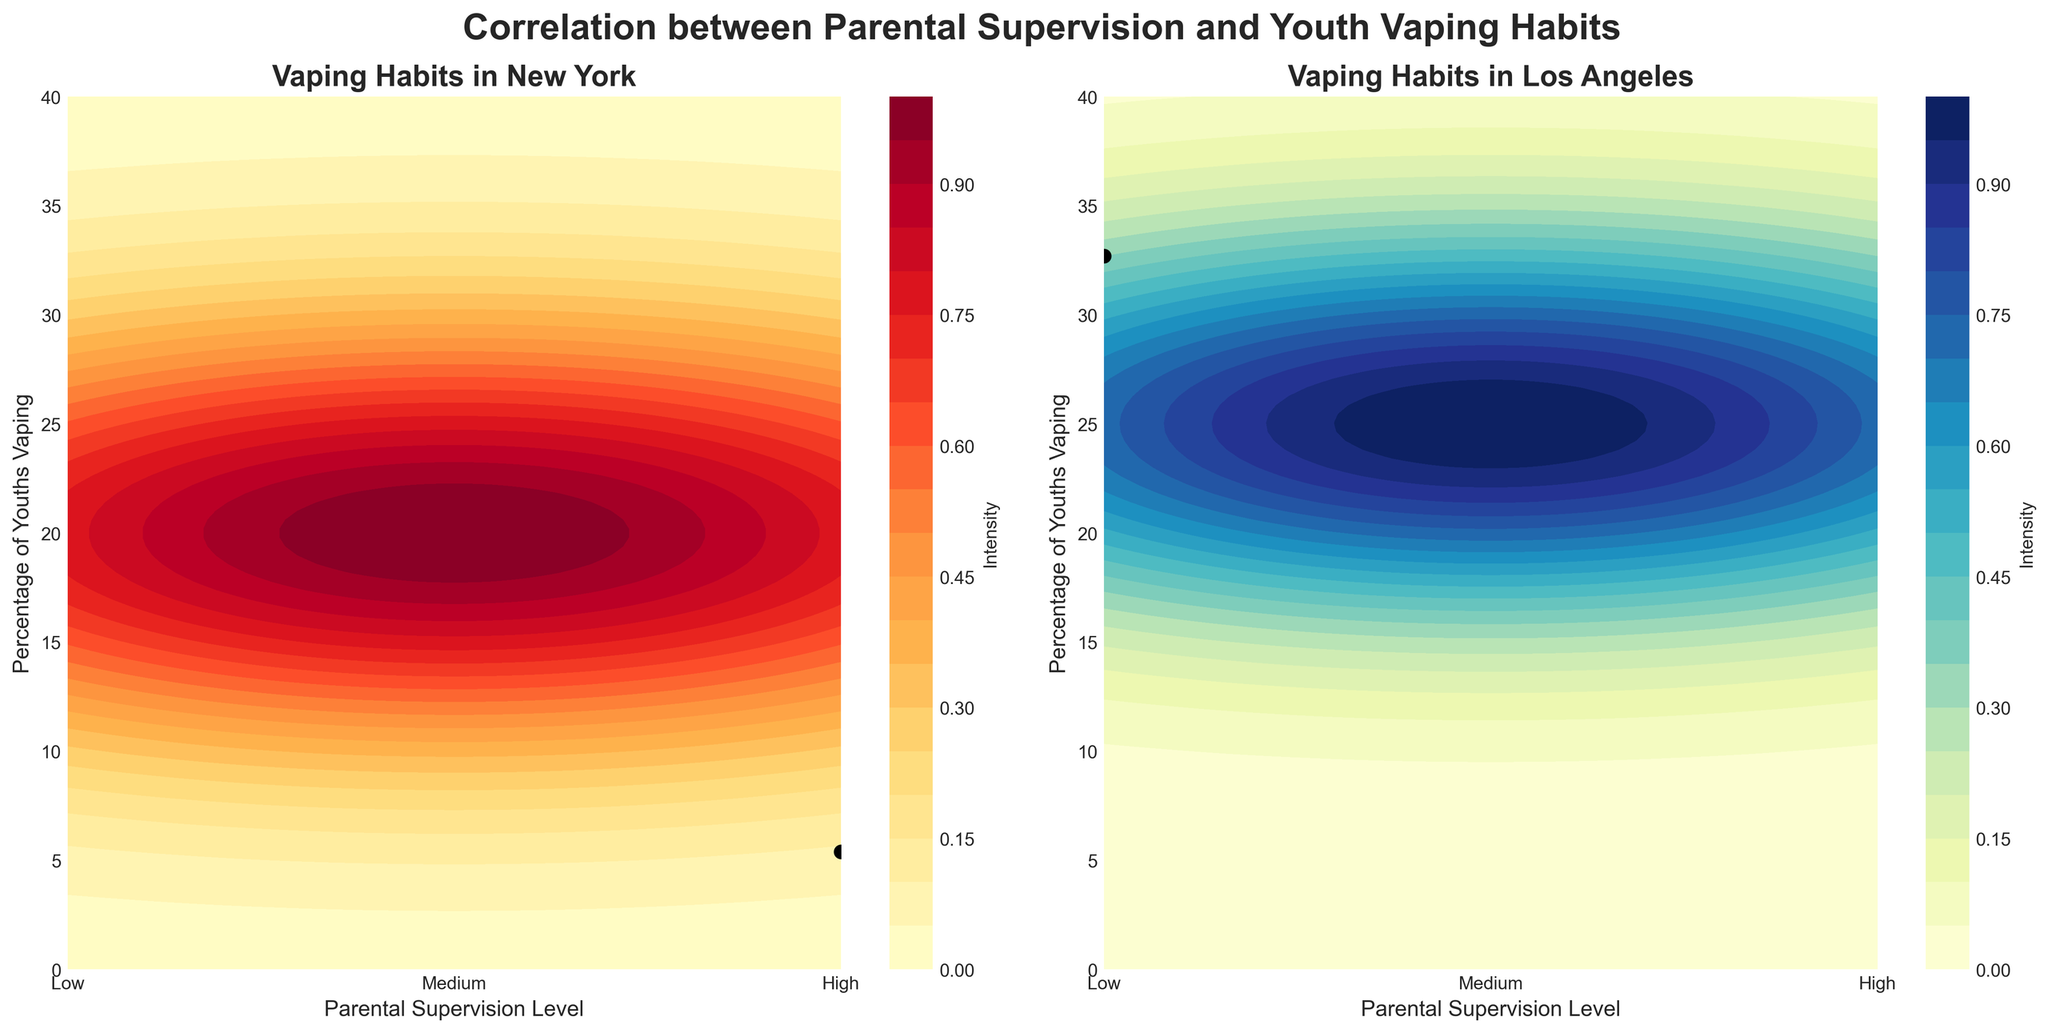What is the title of the first subplot on the left? The first subplot on the left has a title at the top, which can be read directly from the figure.
Answer: Vaping Habits in New York What does the color intensity represent in both subplots? Each subplot has a color bar that indicates what the colors stand for. The intensity is labeled as 'Intensity' in the color bar.
Answer: Intensity What does the y-axis represent in both subplots? The label on the y-axis of both subplots indicates what the y-axis represents.
Answer: Percentage of Youths Vaping Which city has the higher percentage of youths vaping with medium parental supervision? By locating the medium parental supervision marker (5 on the x-axis) and noting the corresponding points for both subplots, we can compare the y-values.
Answer: Los Angeles What is the correlation between parental supervision and youth vaping habits in New York? The contour lines and placement of data points suggest that as the parental supervision level increases, the percentage of youths vaping decreases.
Answer: Negative correlation How many data points are plotted on the left subplot? By counting the distinct data points (black dots) within the subplot for New York, we can determine the number of data points plotted.
Answer: 4 Which city shows a sharper decrease in youth vaping as parental supervision increases from low to high? Comparing the contour gradients of the two subplots, we see which city has steeper contour lines from left (low) to right (high).
Answer: Los Angeles At what parental supervision level does New York show the lowest percentage of youths vaping? Checking the x-axis labels and corresponding y-values for New York, the lowest data point on the graph is found.
Answer: High In Los Angeles, what is the contour intensity level where the percentage of youths vaping is around 32%? Finding the y-value of 32% on the Los Angeles subplot and correlating it with the color bar, we can determine the contour intensity level.
Answer: Approximately 0.72 Is the overall trend of youth vaping consistent between the two cities when parental supervision shifts from high to low? By analyzing the direction of the trend lines (contours) in both subplots, we can compare the trends.
Answer: Yes, both show an increase in youth vaping as supervision decreases 